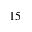<formula> <loc_0><loc_0><loc_500><loc_500>1 5</formula> 